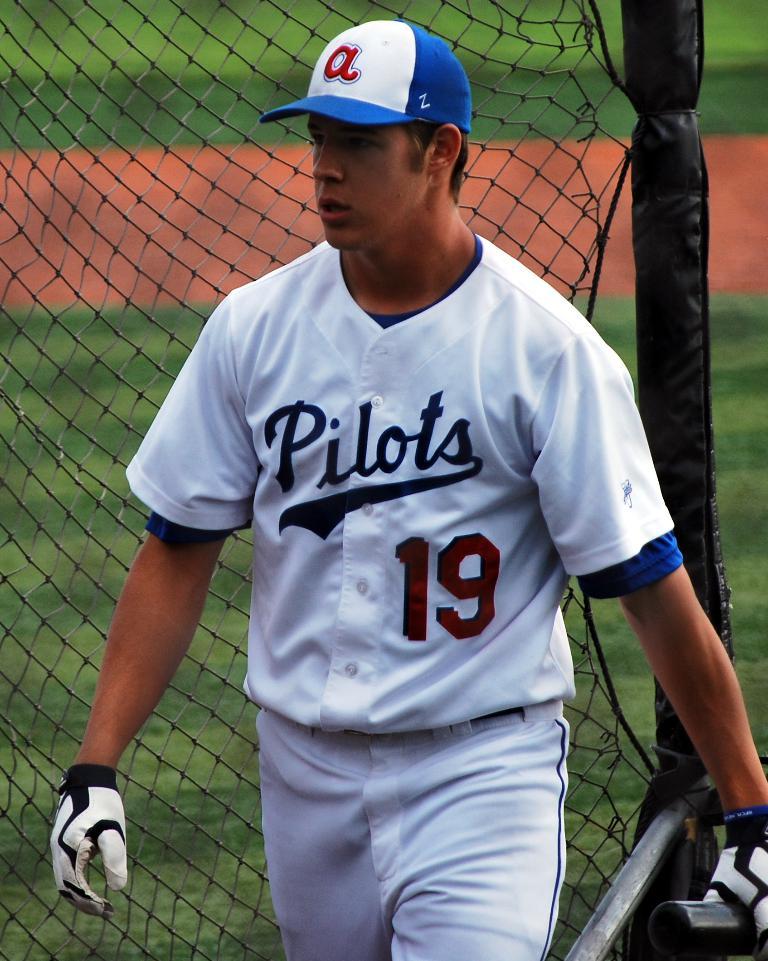What number is the player wearing?
Provide a short and direct response. 19. What team does this gentlemen work for?
Keep it short and to the point. Pilots. 